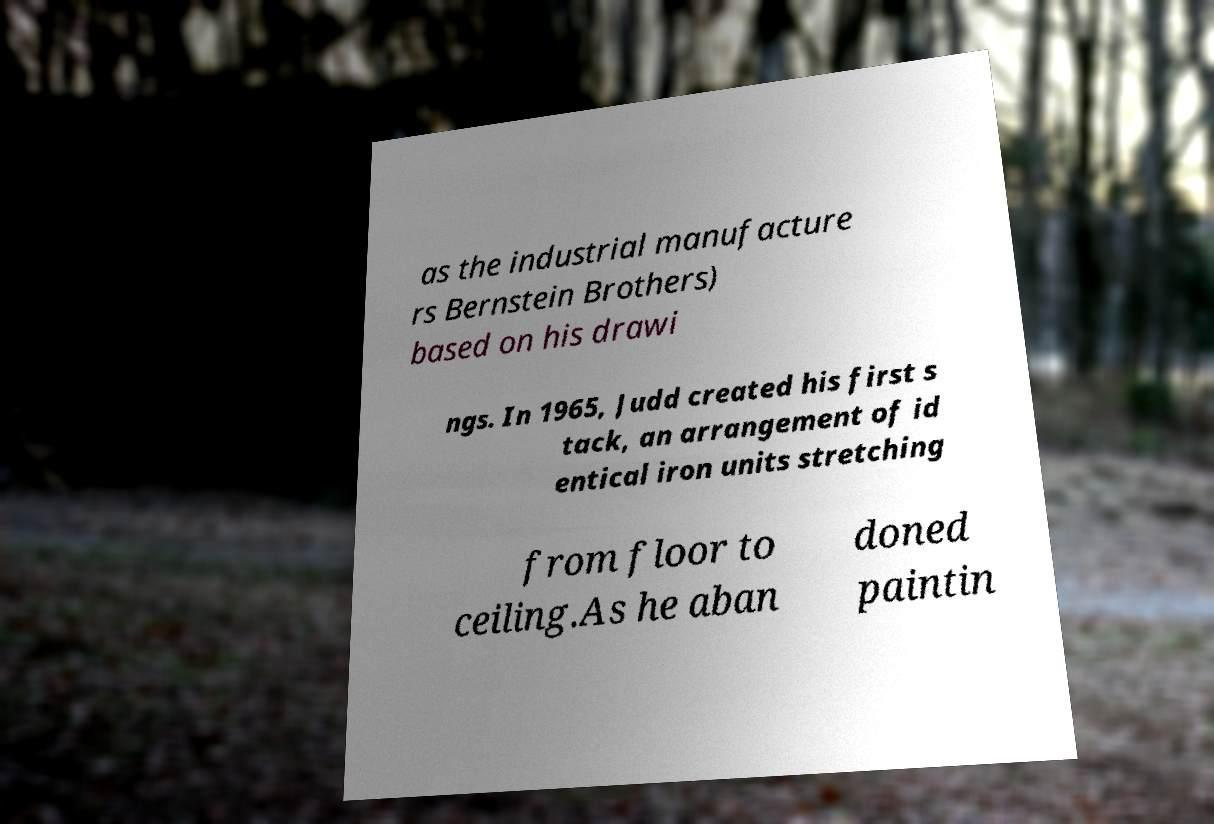For documentation purposes, I need the text within this image transcribed. Could you provide that? as the industrial manufacture rs Bernstein Brothers) based on his drawi ngs. In 1965, Judd created his first s tack, an arrangement of id entical iron units stretching from floor to ceiling.As he aban doned paintin 